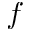Convert formula to latex. <formula><loc_0><loc_0><loc_500><loc_500>f</formula> 